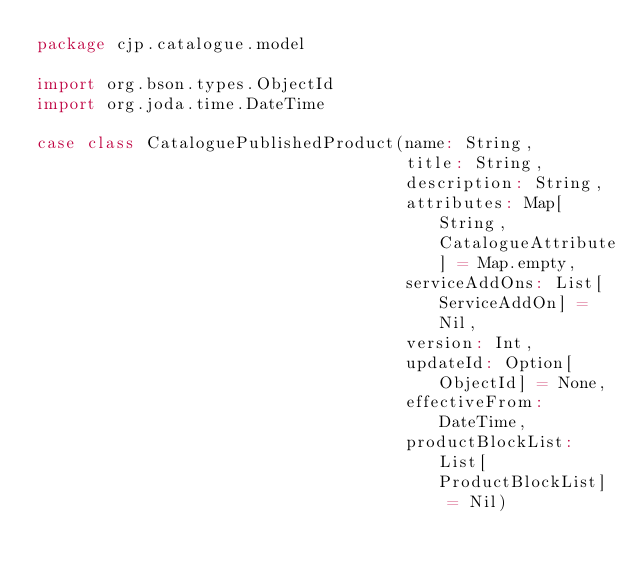Convert code to text. <code><loc_0><loc_0><loc_500><loc_500><_Scala_>package cjp.catalogue.model

import org.bson.types.ObjectId
import org.joda.time.DateTime

case class CataloguePublishedProduct(name: String,
                                     title: String,
                                     description: String,
                                     attributes: Map[String, CatalogueAttribute] = Map.empty,
                                     serviceAddOns: List[ServiceAddOn] = Nil,
                                     version: Int,
                                     updateId: Option[ObjectId] = None,
                                     effectiveFrom: DateTime,
                                     productBlockList: List[ProductBlockList] = Nil)
</code> 